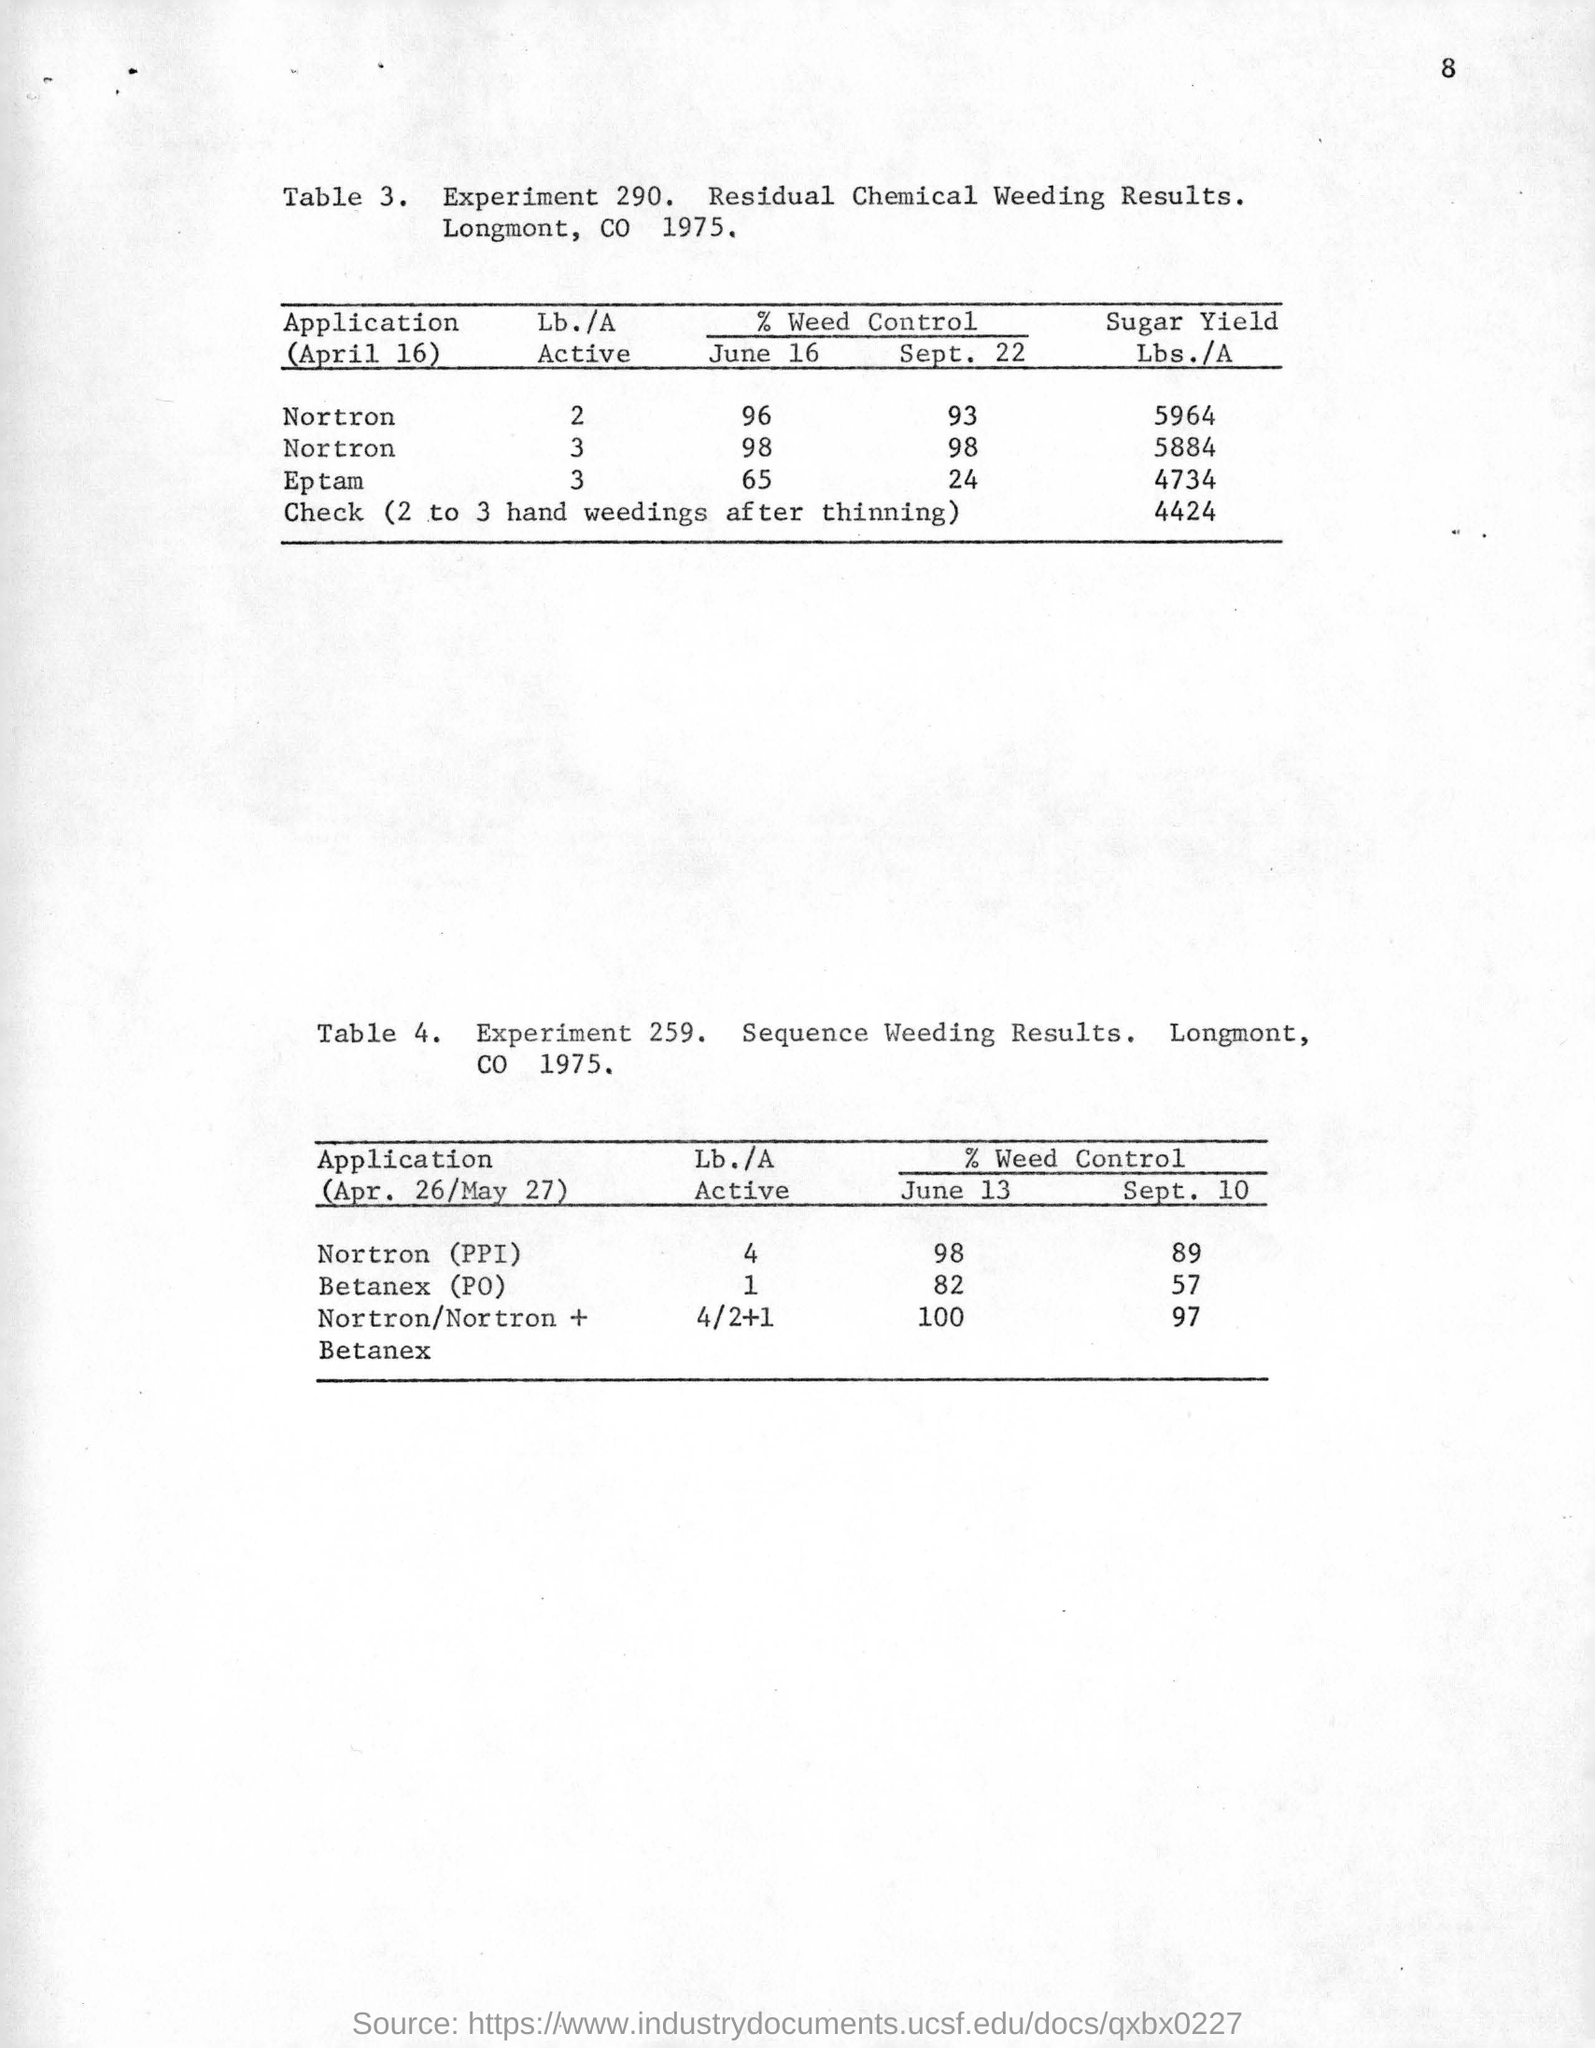What is the Experiment No of Residual Chemical Weeding?
Your answer should be compact. Experiment 290. Which experiment result is mentioned in Table 4?
Keep it short and to the point. Sequence Weeding Results. 